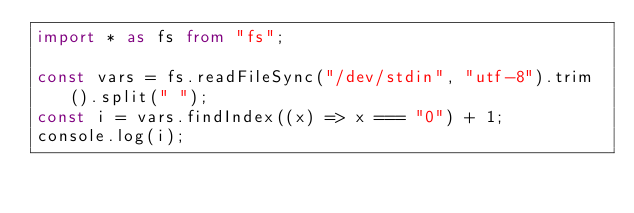<code> <loc_0><loc_0><loc_500><loc_500><_TypeScript_>import * as fs from "fs";

const vars = fs.readFileSync("/dev/stdin", "utf-8").trim().split(" ");
const i = vars.findIndex((x) => x === "0") + 1;
console.log(i);
</code> 